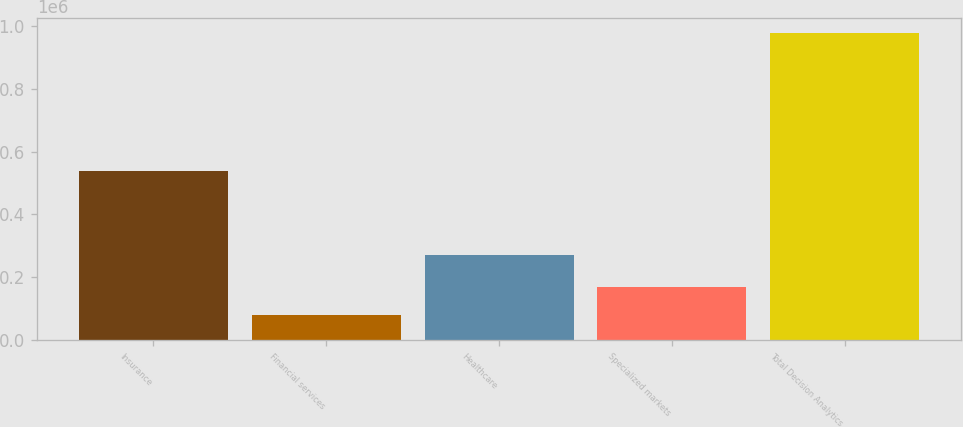<chart> <loc_0><loc_0><loc_500><loc_500><bar_chart><fcel>Insurance<fcel>Financial services<fcel>Healthcare<fcel>Specialized markets<fcel>Total Decision Analytics<nl><fcel>539150<fcel>81113<fcel>271538<fcel>170744<fcel>977427<nl></chart> 